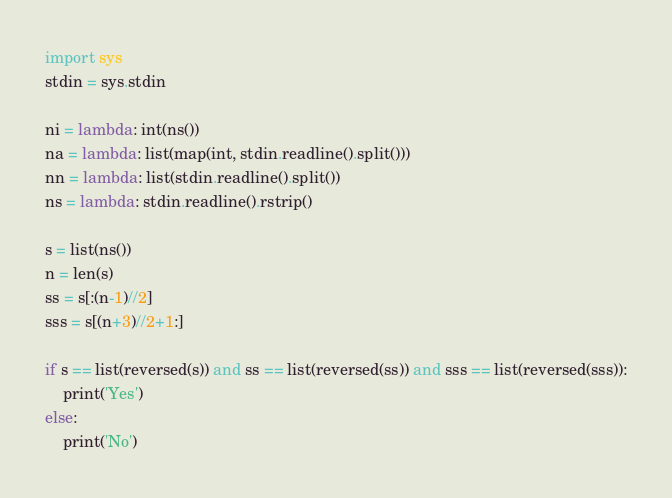Convert code to text. <code><loc_0><loc_0><loc_500><loc_500><_Python_>import sys
stdin = sys.stdin

ni = lambda: int(ns())
na = lambda: list(map(int, stdin.readline().split()))
nn = lambda: list(stdin.readline().split())
ns = lambda: stdin.readline().rstrip()

s = list(ns())
n = len(s)
ss = s[:(n-1)//2]
sss = s[(n+3)//2+1:]

if s == list(reversed(s)) and ss == list(reversed(ss)) and sss == list(reversed(sss)):
    print('Yes')
else:
    print('No')</code> 